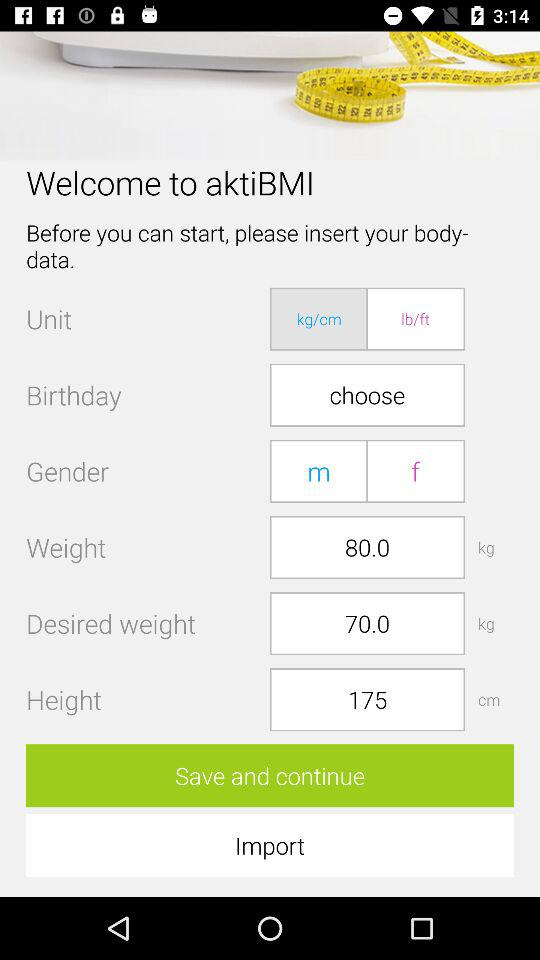What is the weight? The weight is 80 kg. 